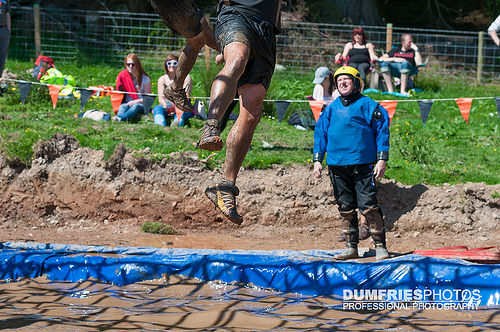<image>
Is there a fence behind the man? Yes. From this viewpoint, the fence is positioned behind the man, with the man partially or fully occluding the fence. 